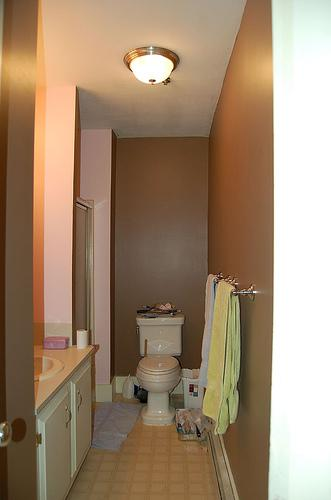Question: what room is this?
Choices:
A. Living room.
B. Bathroom.
C. Kitchen.
D. Bedroom.
Answer with the letter. Answer: B Question: why is the light on?
Choices:
A. It was left on.
B. To read a book.
C. It is dark outside.
D. So you can see.
Answer with the letter. Answer: D Question: what color are the walls?
Choices:
A. Light brown.
B. White.
C. Beige.
D. Green.
Answer with the letter. Answer: A 